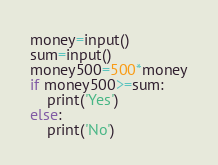Convert code to text. <code><loc_0><loc_0><loc_500><loc_500><_Python_>money=input()
sum=input()
money500=500*money
if money500>=sum:
    print('Yes')
else:
    print('No')</code> 